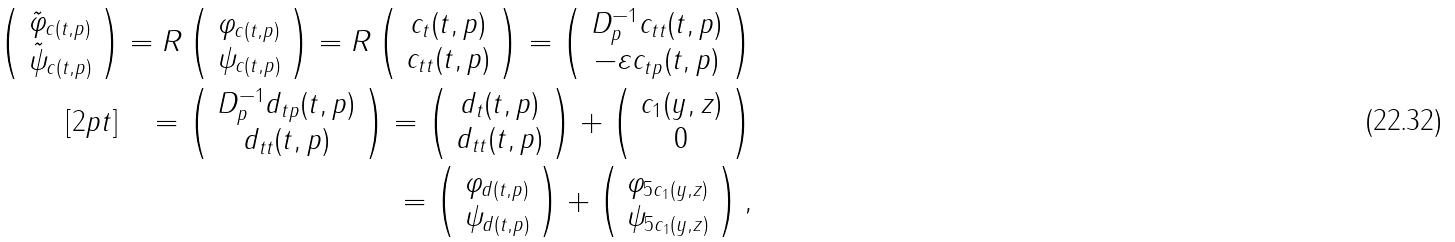Convert formula to latex. <formula><loc_0><loc_0><loc_500><loc_500>\left ( \begin{array} { c } \tilde { \varphi } _ { c ( t , p ) } \\ \tilde { \psi } _ { c ( t , p ) } \end{array} \right ) = R \left ( \begin{array} { c } \varphi _ { c ( t , p ) } \\ \psi _ { c ( t , p ) } \end{array} \right ) = R \left ( \begin{array} { c } c _ { t } ( t , p ) \\ c _ { t t } ( t , p ) \end{array} \right ) = \left ( \begin{array} { c } D _ { p } ^ { - 1 } c _ { t t } ( t , p ) \\ - \varepsilon c _ { t p } ( t , p ) \end{array} \right ) \\ [ 2 p t ] \quad = \left ( \begin{array} { c } D _ { p } ^ { - 1 } d _ { t p } ( t , p ) \\ d _ { t t } ( t , p ) \end{array} \right ) = \left ( \begin{array} { c } d _ { t } ( t , p ) \\ d _ { t t } ( t , p ) \end{array} \right ) + \left ( \begin{array} { c } c _ { 1 } ( y , z ) \\ 0 \end{array} \right ) \\ \quad \, = \left ( \begin{array} { c } \varphi _ { d ( t , p ) } \\ \psi _ { d ( t , p ) } \end{array} \right ) + \left ( \begin{array} { c } \varphi _ { 5 c _ { 1 } ( y , z ) } \\ \psi _ { 5 c _ { 1 } ( y , z ) } \end{array} \right ) ,</formula> 